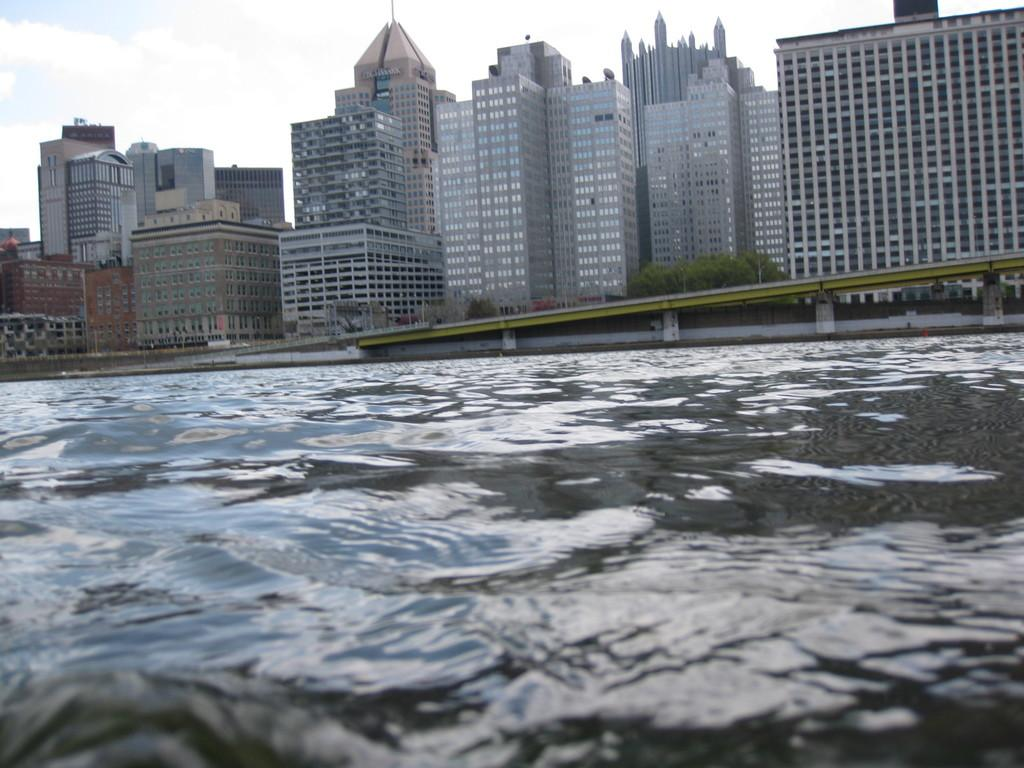What is the primary element visible in the image? There is water in the image. What can be seen in the distance behind the water? There are buildings, plants, and a bridge in the background of the image. How would you describe the sky in the image? The sky is cloudy in the image. How many ducks are swimming in the water in the image? There are no ducks visible in the image. 